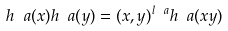<formula> <loc_0><loc_0><loc_500><loc_500>h _ { \ } a ( x ) h _ { \ } a ( y ) = ( x , y ) ^ { l _ { \ } a } h _ { \ } a ( x y )</formula> 